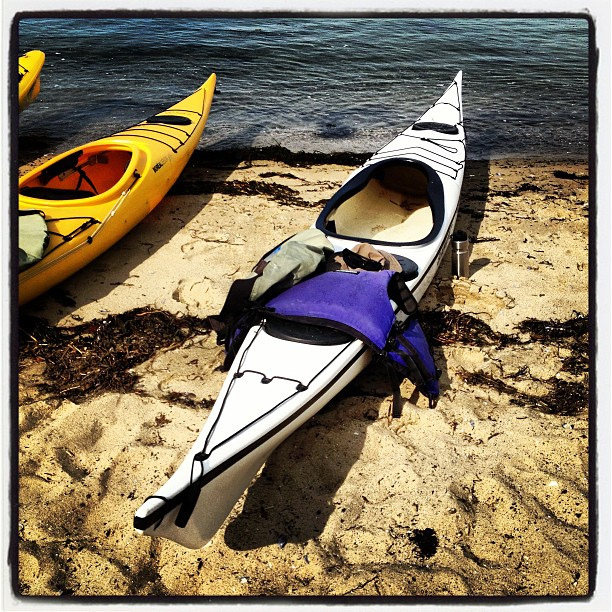<image>Is the water toxic? I don't know if the water is toxic. However, most responders say no. Is the water toxic? I don't know if the water is toxic. It seems that the water is not toxic. 